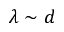<formula> <loc_0><loc_0><loc_500><loc_500>\lambda \sim d</formula> 